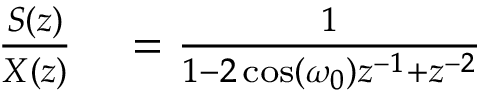<formula> <loc_0><loc_0><loc_500><loc_500>\begin{array} { r l } { { \frac { S ( z ) } { X ( z ) } } } & = { \frac { 1 } { 1 - 2 \cos ( \omega _ { 0 } ) z ^ { - 1 } + z ^ { - 2 } } } } \end{array}</formula> 